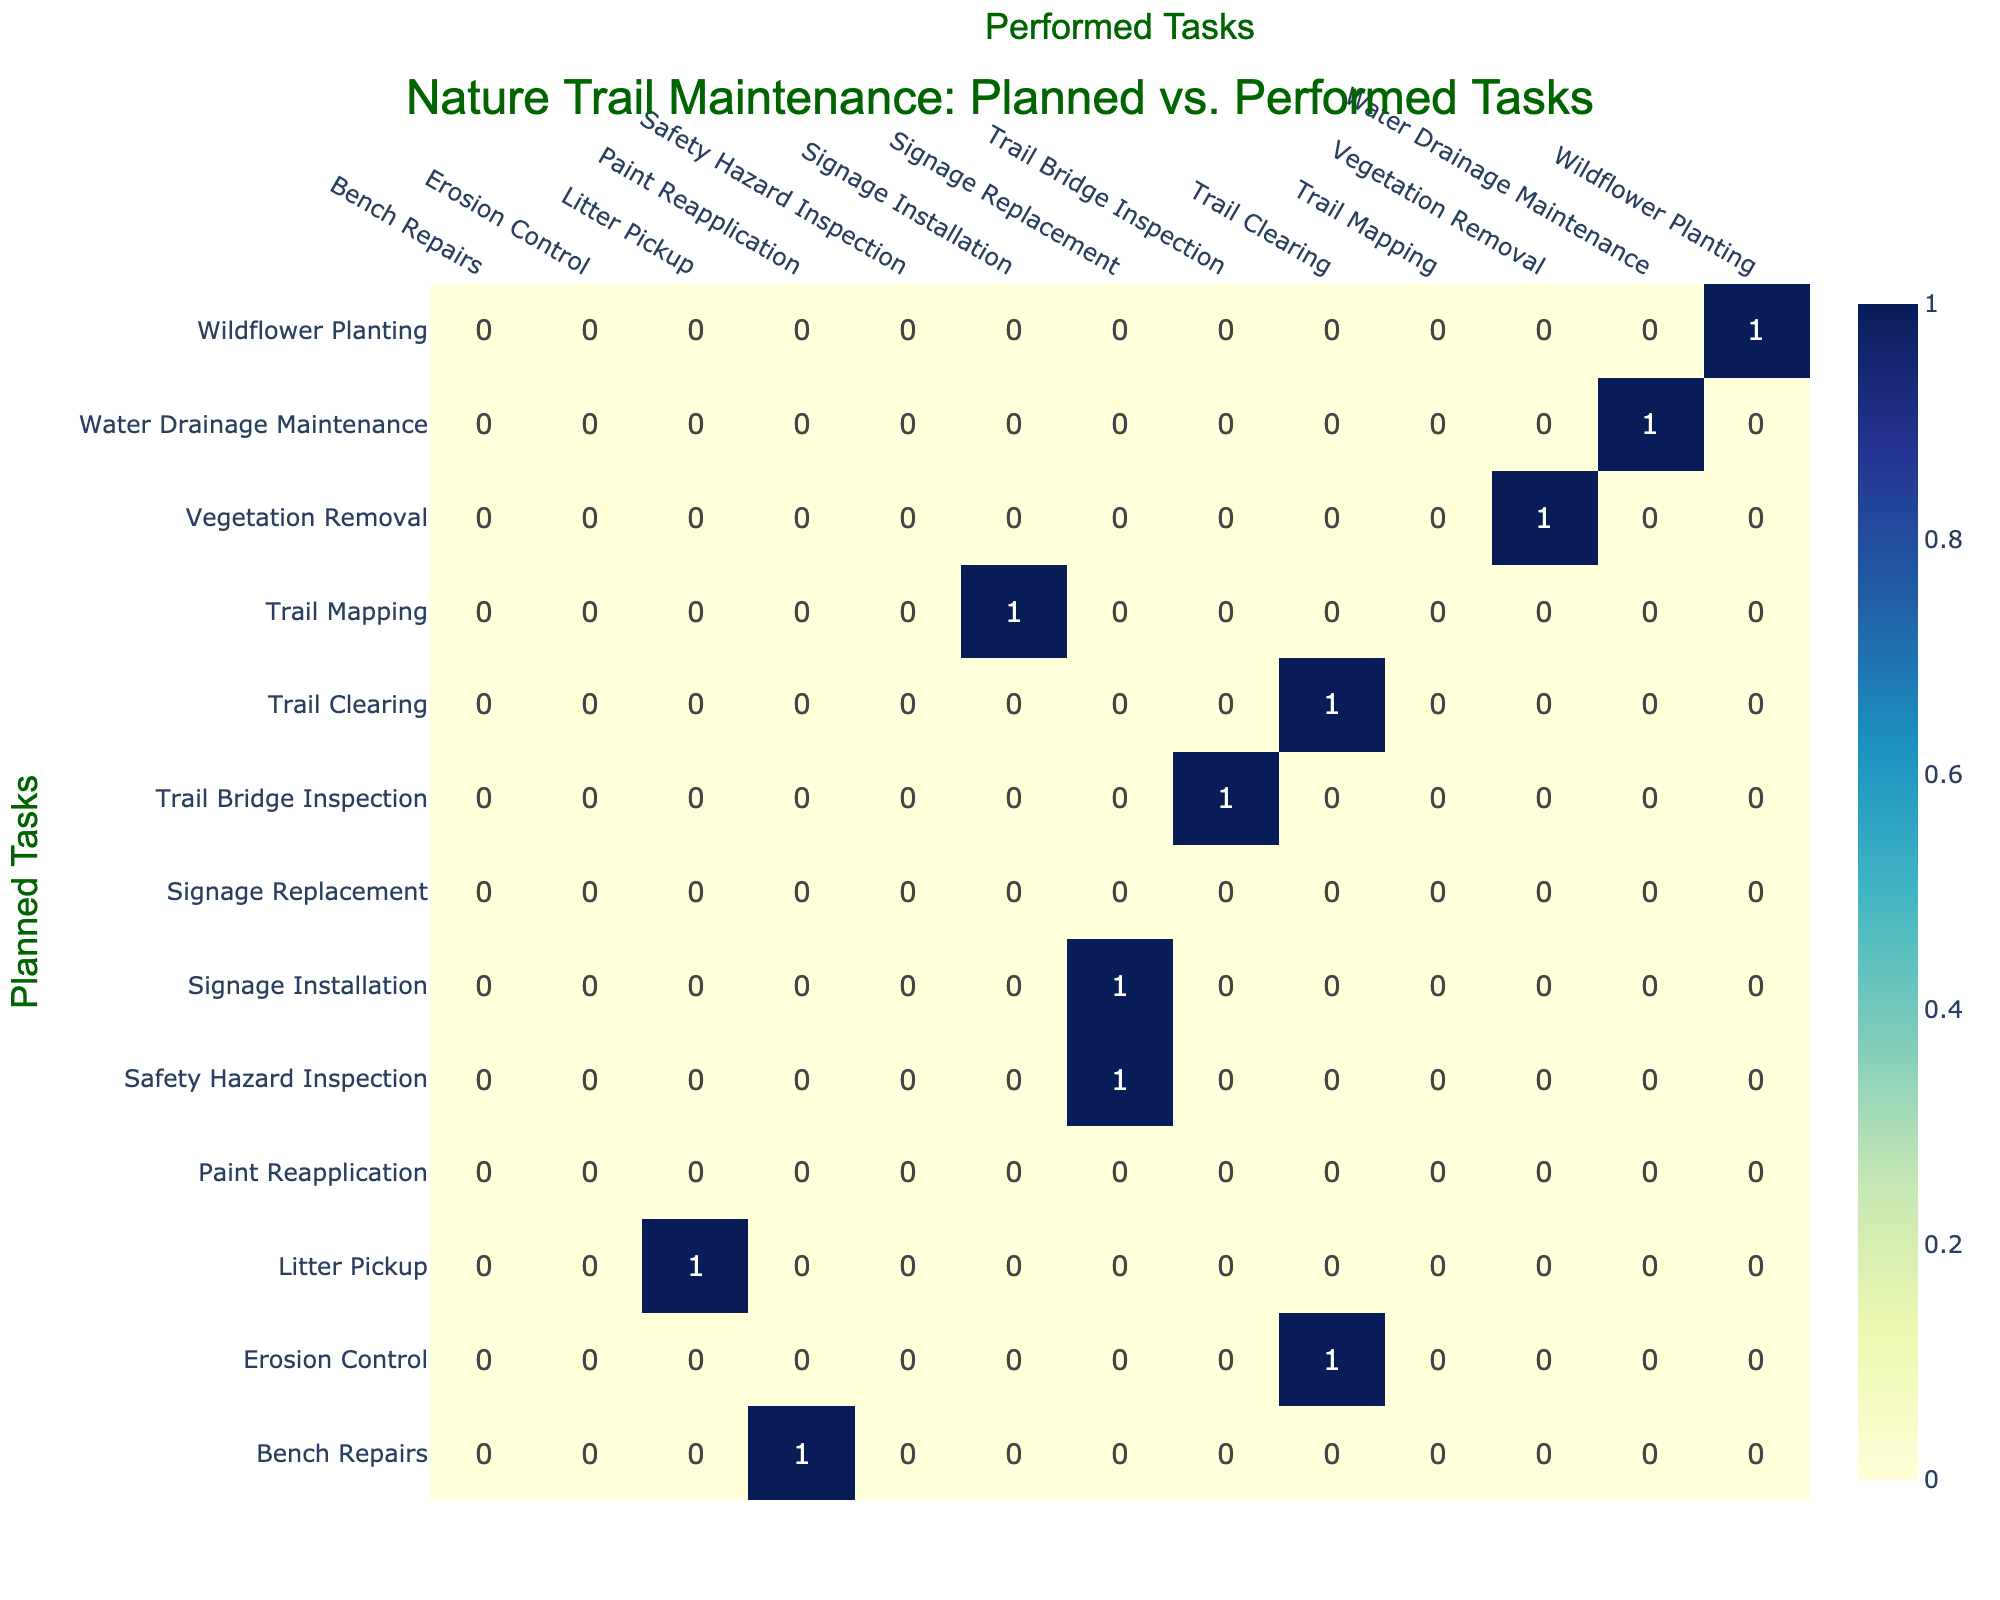What task was planned but not performed at all? By examining the table, we look for planned tasks that do not have any corresponding entries in the performed tasks column. The task "Erosion Control" is listed as planned but is not matched with any performed tasks in the table.
Answer: Erosion Control How many tasks were matched correctly between planned and performed? To determine the count of correctly matched tasks, we identify the diagonal elements in the confusion matrix, which indicates planned tasks that were performed as intended. We find the following matches: Trail Clearing, Wildflower Planting, Litter Pickup, Trail Bridge Inspection, Vegetation Removal, and Water Drainage Maintenance. There are 6 correct matches in total.
Answer: 6 Is there any task that was planned but not replaced? We check the planned tasks list against the performed tasks list to see if any planned tasks do not have any form of replacement. The task "Bench Repairs" is planned but not performed as a replacement at all.
Answer: Yes What is the total number of tasks recorded in the table? To find the total number of tasks, we need to count both the planned and performed tasks. The tasks listed are unique, and by aggregating all unique entries from both categories, we find there are 12 unique tasks.
Answer: 12 Which performed task had the highest frequency compared to planned tasks? We assess each performed task's occurrences by comparing it to planned tasks. In this case, "Trail Clearing" appears as both a planned and performed task, making it one of the most frequent. However, the task "Signage Replacement" appears for the performed tasks but has no matching planned task, neither confirming its frequency with planned ones. Thus, "Trail Clearing" had the highest frequency match.
Answer: Trail Clearing How many tasks were either planned as "Signage Installation" or performed as "Signage Replacement"? We look for occurrences of "Signage Installation" in planned tasks (1 occurrence) and "Signage Replacement" in performed tasks (2 occurrences - as it matches with one planned task). This gives us a total of 3 since both terms are relevant.
Answer: 3 Did any performed tasks exceed the count of their matched planned tasks? Analyzing the tasks shows that the "Signage Replacement" is performed but not planned, and comparing the respective matrices indicates that it indeed exceeds planned in terms of count. We conclude that yes, performed tasks do exceed matches in some cases.
Answer: Yes Which task had the most discrepancies between planned and performed? We identify the gaps between the planned and performed tasks. The comparison shows that signage tasks have discrepancies, with planned "Signage Installation" not having a complete match in performed tasks. Thus, this task has the most significant discrepancies.
Answer: Signage Installation 